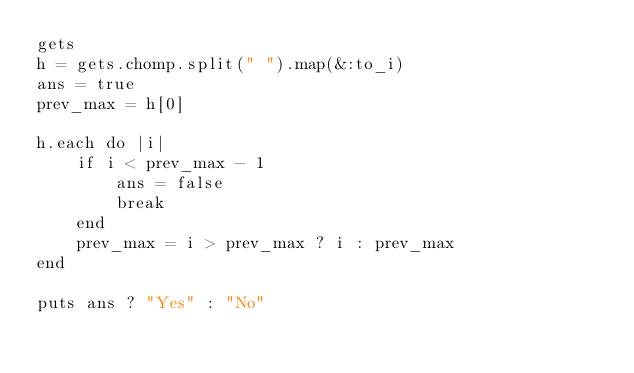<code> <loc_0><loc_0><loc_500><loc_500><_Ruby_>gets
h = gets.chomp.split(" ").map(&:to_i)
ans = true
prev_max = h[0]

h.each do |i|
    if i < prev_max - 1
        ans = false
        break
    end
    prev_max = i > prev_max ? i : prev_max
end

puts ans ? "Yes" : "No"</code> 